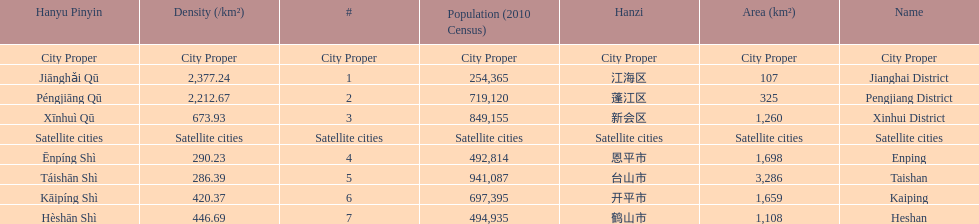What city proper has the smallest area in km2? Jianghai District. 